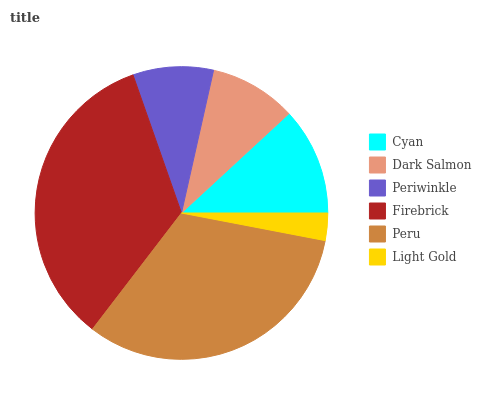Is Light Gold the minimum?
Answer yes or no. Yes. Is Firebrick the maximum?
Answer yes or no. Yes. Is Dark Salmon the minimum?
Answer yes or no. No. Is Dark Salmon the maximum?
Answer yes or no. No. Is Cyan greater than Dark Salmon?
Answer yes or no. Yes. Is Dark Salmon less than Cyan?
Answer yes or no. Yes. Is Dark Salmon greater than Cyan?
Answer yes or no. No. Is Cyan less than Dark Salmon?
Answer yes or no. No. Is Cyan the high median?
Answer yes or no. Yes. Is Dark Salmon the low median?
Answer yes or no. Yes. Is Dark Salmon the high median?
Answer yes or no. No. Is Firebrick the low median?
Answer yes or no. No. 